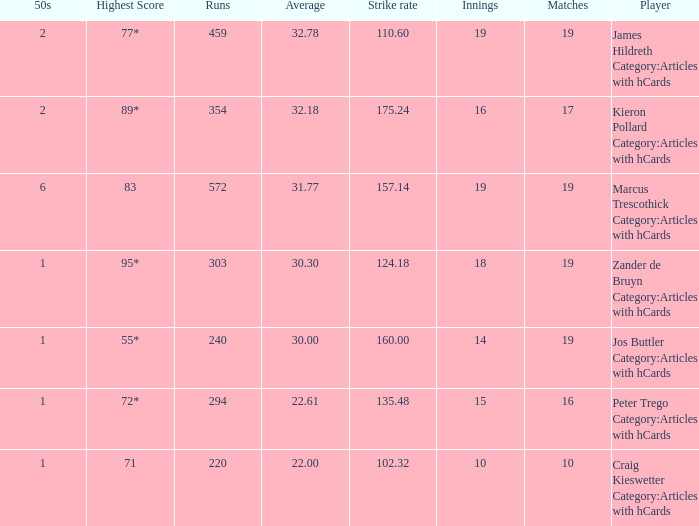What is the highest score for the player with average of 30.00? 55*. 